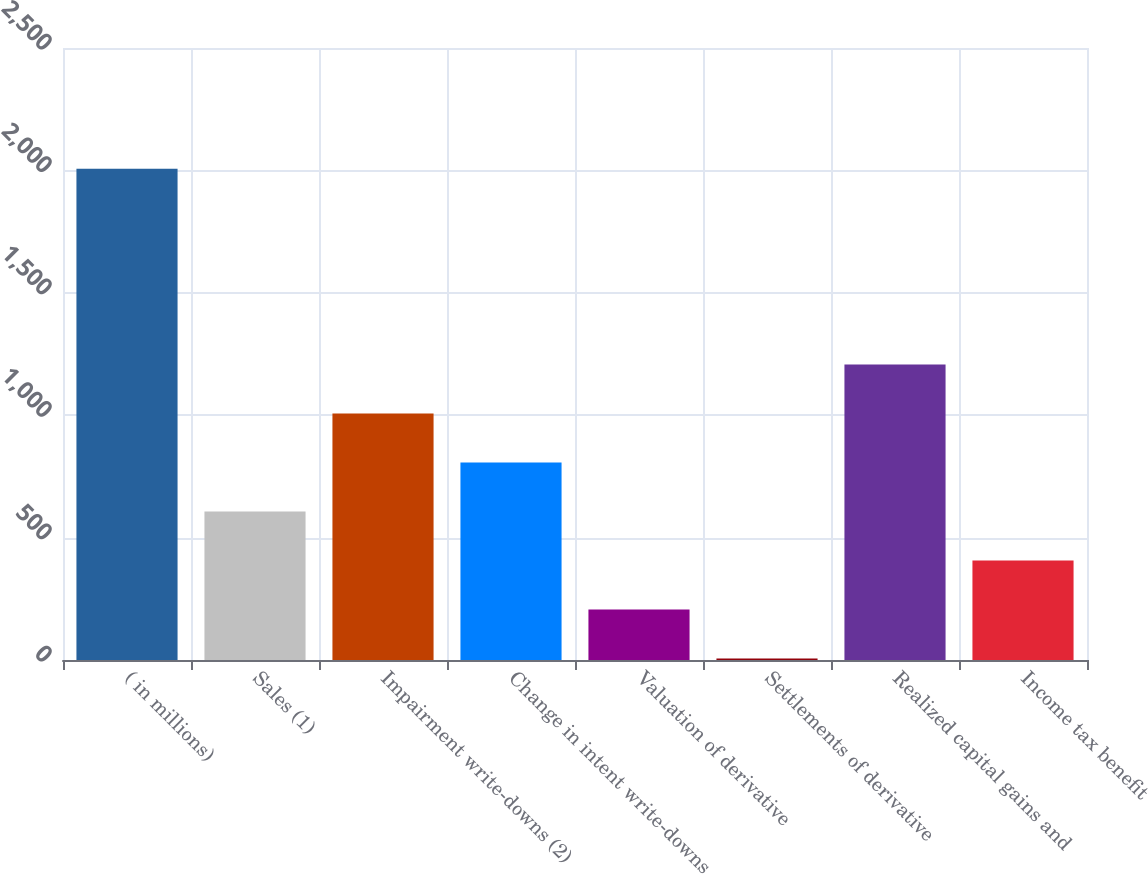<chart> <loc_0><loc_0><loc_500><loc_500><bar_chart><fcel>( in millions)<fcel>Sales (1)<fcel>Impairment write-downs (2)<fcel>Change in intent write-downs<fcel>Valuation of derivative<fcel>Settlements of derivative<fcel>Realized capital gains and<fcel>Income tax benefit<nl><fcel>2007<fcel>606.3<fcel>1006.5<fcel>806.4<fcel>206.1<fcel>6<fcel>1206.6<fcel>406.2<nl></chart> 